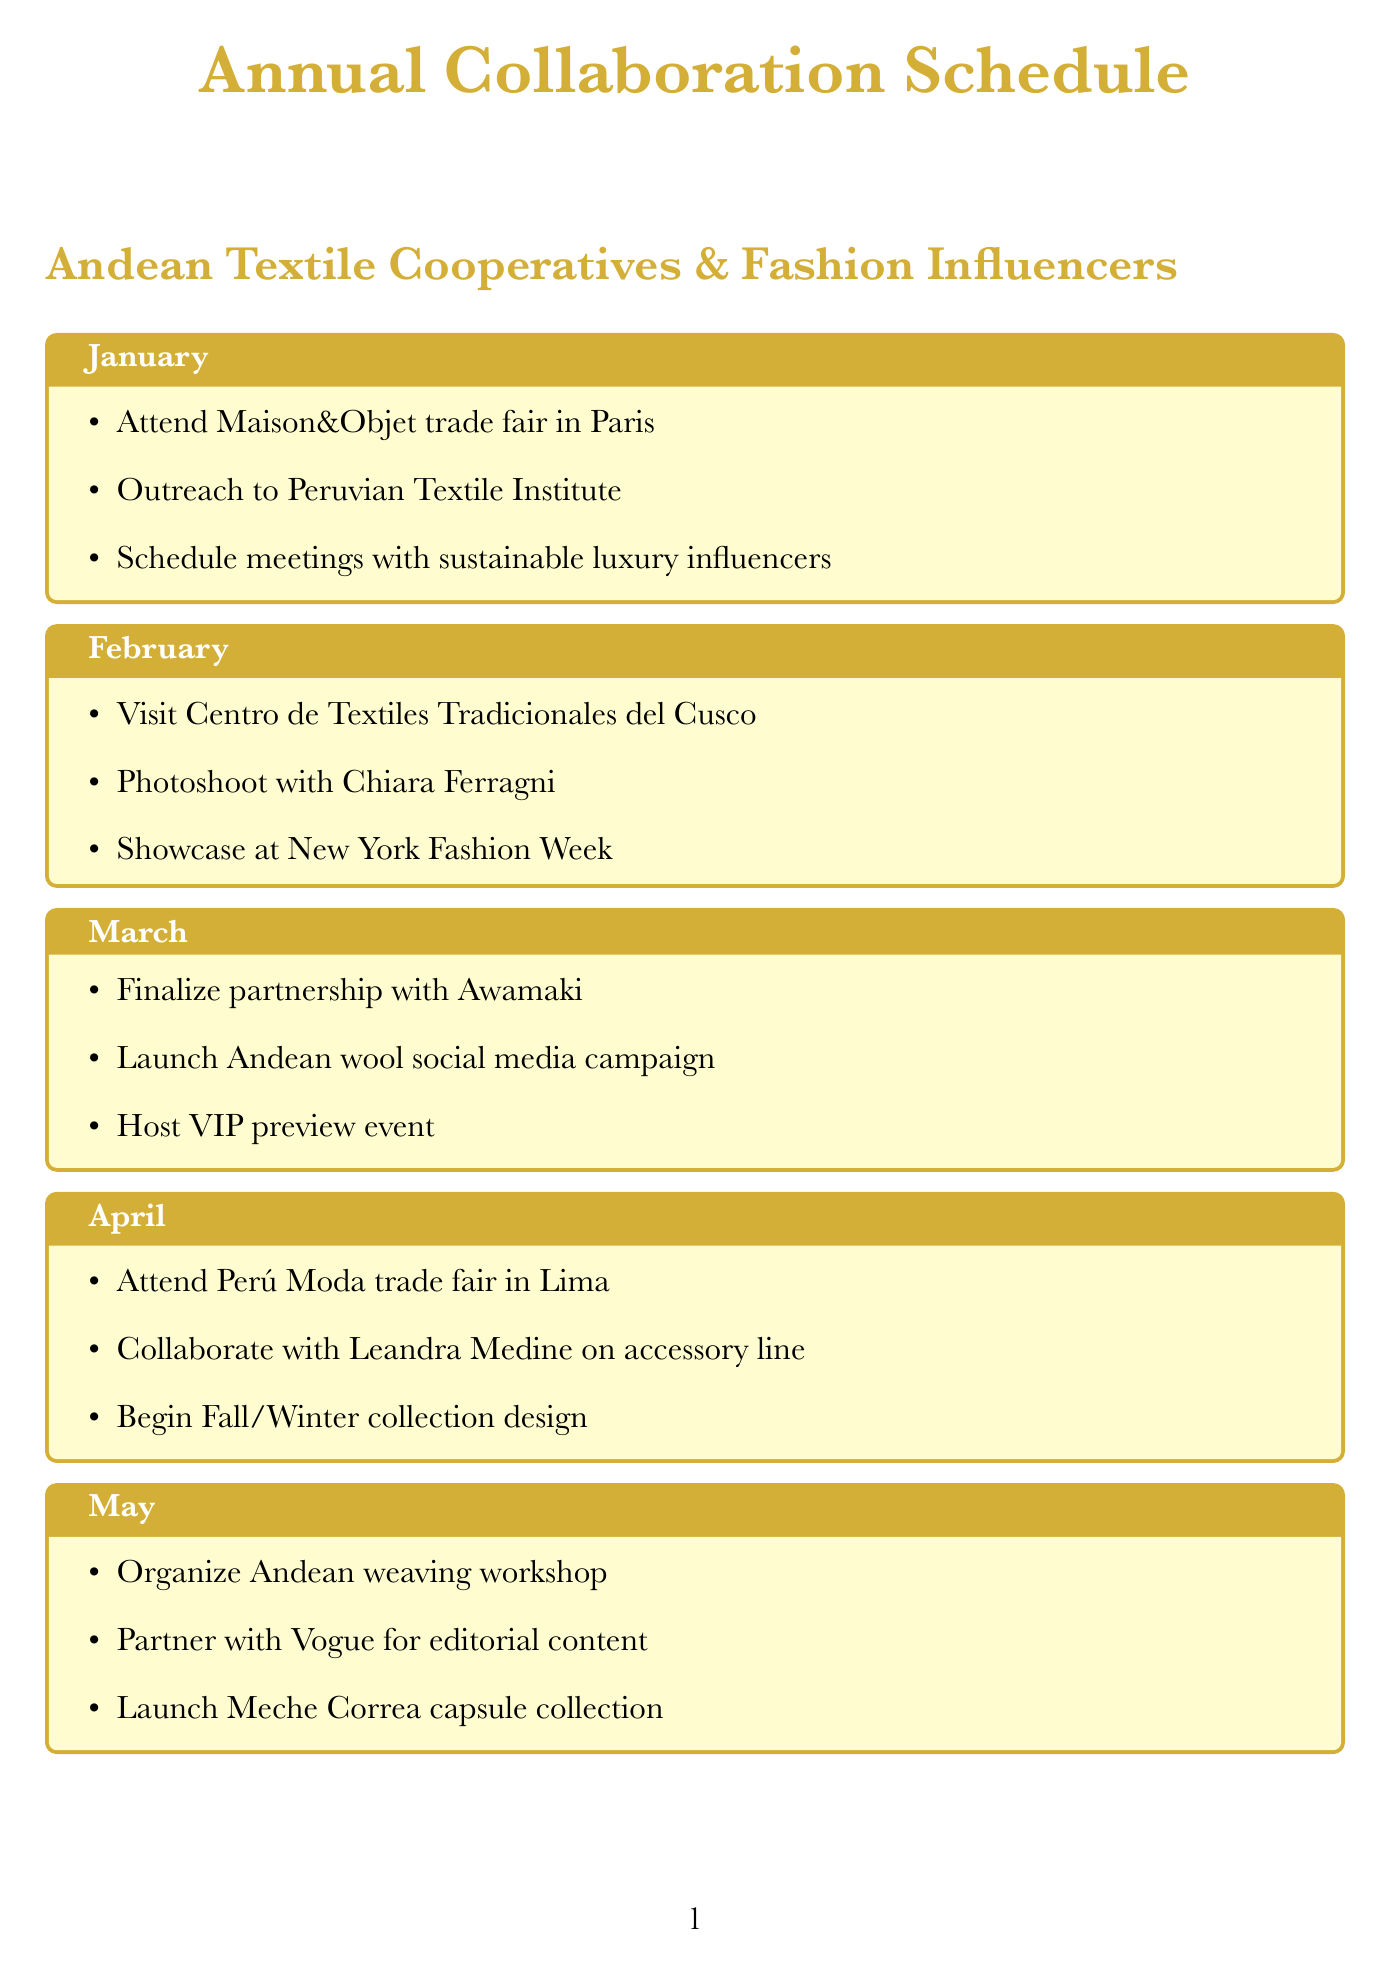What is the trade fair attended in January? The document states the Maison&Objet trade fair in Paris is attended in January.
Answer: Maison&Objet Which influencer is featured in a photoshoot in February? Chiara Ferragni is mentioned in the context of a photoshoot in February.
Answer: Chiara Ferragni What collaboration is finalized in March? The partnership agreement with Awamaki is finalized in March.
Answer: Awamaki How many major events are organized in November? The document mentions three major activities planned for November.
Answer: Three Which textile is highlighted in the social media campaign launched in March? The campaign emphasizes the unique properties of Andean wool.
Answer: Andean wool What is the primary focus of the December outreach activities? The outreach in December is aimed at next year's collaborations with Andean cooperatives and influencers.
Answer: Next year's collaborations What special collection is launched in May? The document specifies a capsule collection with Peruvian designer Meche Correa that is launched in May.
Answer: Meche Correa capsule collection Which month features a collaboration with influencer Emmanuelle Alt? The collaboration with Emmanuelle Alt occurs in June.
Answer: June What is the location of the Alpaca Fiesta attended in October? The document indicates that the Alpaca Fiesta is attended in Arequipa, Peru, in October.
Answer: Arequipa, Peru 